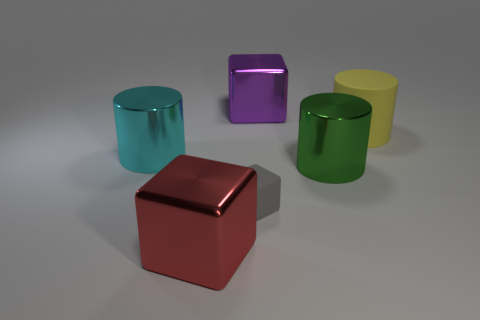There is another big object that is the same shape as the purple object; what color is it?
Give a very brief answer. Red. How many metallic objects have the same color as the tiny block?
Offer a very short reply. 0. The red metal thing has what size?
Offer a very short reply. Large. Do the purple cube and the red metal cube have the same size?
Offer a very short reply. Yes. There is a thing that is both right of the purple block and behind the large green object; what is its color?
Ensure brevity in your answer.  Yellow. What number of red objects have the same material as the small cube?
Provide a short and direct response. 0. How many big cyan things are there?
Your answer should be compact. 1. Do the yellow cylinder and the shiny cube on the right side of the large red shiny thing have the same size?
Provide a short and direct response. Yes. What is the material of the large cube right of the big cube that is in front of the purple thing?
Offer a terse response. Metal. There is a rubber thing on the left side of the big shiny block that is behind the big matte cylinder behind the big green shiny object; what size is it?
Give a very brief answer. Small. 